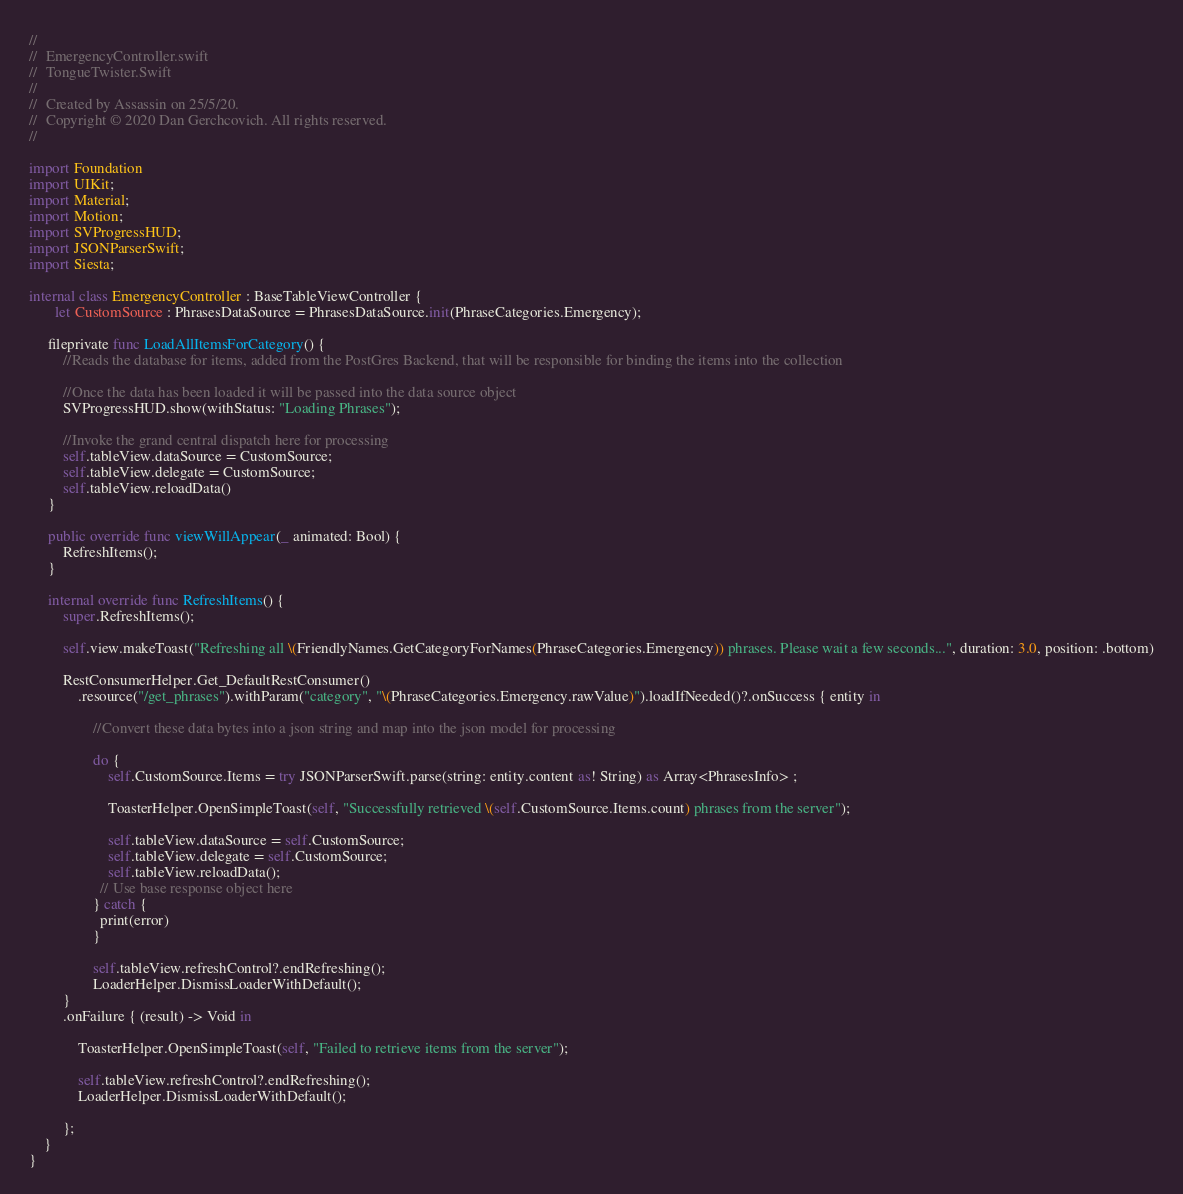Convert code to text. <code><loc_0><loc_0><loc_500><loc_500><_Swift_>//
//  EmergencyController.swift
//  TongueTwister.Swift
//
//  Created by Assassin on 25/5/20.
//  Copyright © 2020 Dan Gerchcovich. All rights reserved.
//

import Foundation
import UIKit;
import Material;
import Motion;
import SVProgressHUD;
import JSONParserSwift;
import Siesta;

internal class EmergencyController : BaseTableViewController {
       let CustomSource : PhrasesDataSource = PhrasesDataSource.init(PhraseCategories.Emergency);
     
     fileprivate func LoadAllItemsForCategory() {
         //Reads the database for items, added from the PostGres Backend, that will be responsible for binding the items into the collection
         
         //Once the data has been loaded it will be passed into the data source object
         SVProgressHUD.show(withStatus: "Loading Phrases");
         
         //Invoke the grand central dispatch here for processing
         self.tableView.dataSource = CustomSource;
         self.tableView.delegate = CustomSource;
         self.tableView.reloadData()
     }

     public override func viewWillAppear(_ animated: Bool) {
         RefreshItems();
     }
     
     internal override func RefreshItems() {
         super.RefreshItems();
         
         self.view.makeToast("Refreshing all \(FriendlyNames.GetCategoryForNames(PhraseCategories.Emergency)) phrases. Please wait a few seconds...", duration: 3.0, position: .bottom)
         
         RestConsumerHelper.Get_DefaultRestConsumer()
             .resource("/get_phrases").withParam("category", "\(PhraseCategories.Emergency.rawValue)").loadIfNeeded()?.onSuccess { entity in
                 
                 //Convert these data bytes into a json string and map into the json model for processing
                 
                 do {
                     self.CustomSource.Items = try JSONParserSwift.parse(string: entity.content as! String) as Array<PhrasesInfo> ;
                     
                     ToasterHelper.OpenSimpleToast(self, "Successfully retrieved \(self.CustomSource.Items.count) phrases from the server");
                     
                     self.tableView.dataSource = self.CustomSource;
                     self.tableView.delegate = self.CustomSource;
                     self.tableView.reloadData();
                   // Use base response object here
                 } catch {
                   print(error)
                 }
                 
                 self.tableView.refreshControl?.endRefreshing();
                 LoaderHelper.DismissLoaderWithDefault();
         }
         .onFailure { (result) -> Void in
             
             ToasterHelper.OpenSimpleToast(self, "Failed to retrieve items from the server");
             
             self.tableView.refreshControl?.endRefreshing();
             LoaderHelper.DismissLoaderWithDefault();
             
         };
    }
}

</code> 